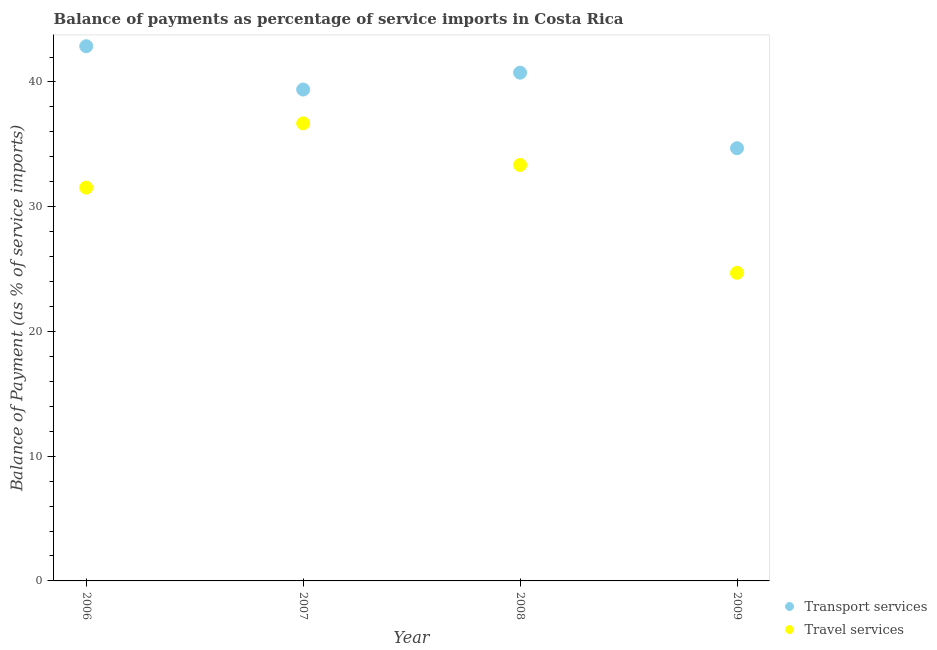What is the balance of payments of transport services in 2006?
Your response must be concise. 42.87. Across all years, what is the maximum balance of payments of travel services?
Your answer should be compact. 36.68. Across all years, what is the minimum balance of payments of travel services?
Make the answer very short. 24.7. In which year was the balance of payments of transport services maximum?
Provide a short and direct response. 2006. In which year was the balance of payments of transport services minimum?
Keep it short and to the point. 2009. What is the total balance of payments of travel services in the graph?
Make the answer very short. 126.26. What is the difference between the balance of payments of transport services in 2007 and that in 2008?
Offer a very short reply. -1.35. What is the difference between the balance of payments of travel services in 2006 and the balance of payments of transport services in 2009?
Offer a very short reply. -3.16. What is the average balance of payments of transport services per year?
Keep it short and to the point. 39.42. In the year 2006, what is the difference between the balance of payments of travel services and balance of payments of transport services?
Your answer should be compact. -11.34. In how many years, is the balance of payments of travel services greater than 12 %?
Offer a very short reply. 4. What is the ratio of the balance of payments of transport services in 2007 to that in 2008?
Offer a terse response. 0.97. Is the balance of payments of transport services in 2007 less than that in 2008?
Provide a succinct answer. Yes. Is the difference between the balance of payments of transport services in 2006 and 2007 greater than the difference between the balance of payments of travel services in 2006 and 2007?
Offer a very short reply. Yes. What is the difference between the highest and the second highest balance of payments of transport services?
Give a very brief answer. 2.12. What is the difference between the highest and the lowest balance of payments of transport services?
Your answer should be compact. 8.18. How many dotlines are there?
Keep it short and to the point. 2. How many years are there in the graph?
Offer a terse response. 4. Does the graph contain grids?
Your answer should be very brief. No. How many legend labels are there?
Offer a very short reply. 2. How are the legend labels stacked?
Provide a short and direct response. Vertical. What is the title of the graph?
Your answer should be very brief. Balance of payments as percentage of service imports in Costa Rica. What is the label or title of the Y-axis?
Ensure brevity in your answer.  Balance of Payment (as % of service imports). What is the Balance of Payment (as % of service imports) of Transport services in 2006?
Provide a succinct answer. 42.87. What is the Balance of Payment (as % of service imports) of Travel services in 2006?
Provide a succinct answer. 31.53. What is the Balance of Payment (as % of service imports) of Transport services in 2007?
Ensure brevity in your answer.  39.39. What is the Balance of Payment (as % of service imports) of Travel services in 2007?
Provide a short and direct response. 36.68. What is the Balance of Payment (as % of service imports) of Transport services in 2008?
Provide a short and direct response. 40.74. What is the Balance of Payment (as % of service imports) of Travel services in 2008?
Give a very brief answer. 33.35. What is the Balance of Payment (as % of service imports) in Transport services in 2009?
Your answer should be compact. 34.69. What is the Balance of Payment (as % of service imports) in Travel services in 2009?
Make the answer very short. 24.7. Across all years, what is the maximum Balance of Payment (as % of service imports) in Transport services?
Give a very brief answer. 42.87. Across all years, what is the maximum Balance of Payment (as % of service imports) of Travel services?
Your response must be concise. 36.68. Across all years, what is the minimum Balance of Payment (as % of service imports) in Transport services?
Your answer should be compact. 34.69. Across all years, what is the minimum Balance of Payment (as % of service imports) in Travel services?
Keep it short and to the point. 24.7. What is the total Balance of Payment (as % of service imports) of Transport services in the graph?
Offer a very short reply. 157.69. What is the total Balance of Payment (as % of service imports) of Travel services in the graph?
Keep it short and to the point. 126.26. What is the difference between the Balance of Payment (as % of service imports) in Transport services in 2006 and that in 2007?
Give a very brief answer. 3.47. What is the difference between the Balance of Payment (as % of service imports) in Travel services in 2006 and that in 2007?
Offer a very short reply. -5.15. What is the difference between the Balance of Payment (as % of service imports) of Transport services in 2006 and that in 2008?
Offer a very short reply. 2.12. What is the difference between the Balance of Payment (as % of service imports) of Travel services in 2006 and that in 2008?
Ensure brevity in your answer.  -1.82. What is the difference between the Balance of Payment (as % of service imports) of Transport services in 2006 and that in 2009?
Your response must be concise. 8.18. What is the difference between the Balance of Payment (as % of service imports) of Travel services in 2006 and that in 2009?
Keep it short and to the point. 6.83. What is the difference between the Balance of Payment (as % of service imports) of Transport services in 2007 and that in 2008?
Ensure brevity in your answer.  -1.35. What is the difference between the Balance of Payment (as % of service imports) in Travel services in 2007 and that in 2008?
Keep it short and to the point. 3.33. What is the difference between the Balance of Payment (as % of service imports) in Transport services in 2007 and that in 2009?
Your answer should be very brief. 4.7. What is the difference between the Balance of Payment (as % of service imports) of Travel services in 2007 and that in 2009?
Your answer should be very brief. 11.98. What is the difference between the Balance of Payment (as % of service imports) in Transport services in 2008 and that in 2009?
Give a very brief answer. 6.06. What is the difference between the Balance of Payment (as % of service imports) in Travel services in 2008 and that in 2009?
Make the answer very short. 8.65. What is the difference between the Balance of Payment (as % of service imports) of Transport services in 2006 and the Balance of Payment (as % of service imports) of Travel services in 2007?
Provide a succinct answer. 6.18. What is the difference between the Balance of Payment (as % of service imports) of Transport services in 2006 and the Balance of Payment (as % of service imports) of Travel services in 2008?
Provide a succinct answer. 9.52. What is the difference between the Balance of Payment (as % of service imports) of Transport services in 2006 and the Balance of Payment (as % of service imports) of Travel services in 2009?
Your answer should be compact. 18.17. What is the difference between the Balance of Payment (as % of service imports) in Transport services in 2007 and the Balance of Payment (as % of service imports) in Travel services in 2008?
Make the answer very short. 6.04. What is the difference between the Balance of Payment (as % of service imports) of Transport services in 2007 and the Balance of Payment (as % of service imports) of Travel services in 2009?
Ensure brevity in your answer.  14.69. What is the difference between the Balance of Payment (as % of service imports) in Transport services in 2008 and the Balance of Payment (as % of service imports) in Travel services in 2009?
Provide a short and direct response. 16.04. What is the average Balance of Payment (as % of service imports) in Transport services per year?
Give a very brief answer. 39.42. What is the average Balance of Payment (as % of service imports) in Travel services per year?
Provide a succinct answer. 31.56. In the year 2006, what is the difference between the Balance of Payment (as % of service imports) of Transport services and Balance of Payment (as % of service imports) of Travel services?
Give a very brief answer. 11.34. In the year 2007, what is the difference between the Balance of Payment (as % of service imports) of Transport services and Balance of Payment (as % of service imports) of Travel services?
Your answer should be compact. 2.71. In the year 2008, what is the difference between the Balance of Payment (as % of service imports) in Transport services and Balance of Payment (as % of service imports) in Travel services?
Make the answer very short. 7.4. In the year 2009, what is the difference between the Balance of Payment (as % of service imports) in Transport services and Balance of Payment (as % of service imports) in Travel services?
Keep it short and to the point. 9.99. What is the ratio of the Balance of Payment (as % of service imports) in Transport services in 2006 to that in 2007?
Your answer should be very brief. 1.09. What is the ratio of the Balance of Payment (as % of service imports) of Travel services in 2006 to that in 2007?
Your answer should be very brief. 0.86. What is the ratio of the Balance of Payment (as % of service imports) of Transport services in 2006 to that in 2008?
Give a very brief answer. 1.05. What is the ratio of the Balance of Payment (as % of service imports) in Travel services in 2006 to that in 2008?
Make the answer very short. 0.95. What is the ratio of the Balance of Payment (as % of service imports) in Transport services in 2006 to that in 2009?
Make the answer very short. 1.24. What is the ratio of the Balance of Payment (as % of service imports) of Travel services in 2006 to that in 2009?
Make the answer very short. 1.28. What is the ratio of the Balance of Payment (as % of service imports) of Transport services in 2007 to that in 2008?
Offer a very short reply. 0.97. What is the ratio of the Balance of Payment (as % of service imports) in Travel services in 2007 to that in 2008?
Your response must be concise. 1.1. What is the ratio of the Balance of Payment (as % of service imports) in Transport services in 2007 to that in 2009?
Offer a terse response. 1.14. What is the ratio of the Balance of Payment (as % of service imports) of Travel services in 2007 to that in 2009?
Offer a terse response. 1.49. What is the ratio of the Balance of Payment (as % of service imports) of Transport services in 2008 to that in 2009?
Keep it short and to the point. 1.17. What is the ratio of the Balance of Payment (as % of service imports) in Travel services in 2008 to that in 2009?
Offer a terse response. 1.35. What is the difference between the highest and the second highest Balance of Payment (as % of service imports) of Transport services?
Keep it short and to the point. 2.12. What is the difference between the highest and the second highest Balance of Payment (as % of service imports) in Travel services?
Keep it short and to the point. 3.33. What is the difference between the highest and the lowest Balance of Payment (as % of service imports) in Transport services?
Make the answer very short. 8.18. What is the difference between the highest and the lowest Balance of Payment (as % of service imports) in Travel services?
Your answer should be very brief. 11.98. 